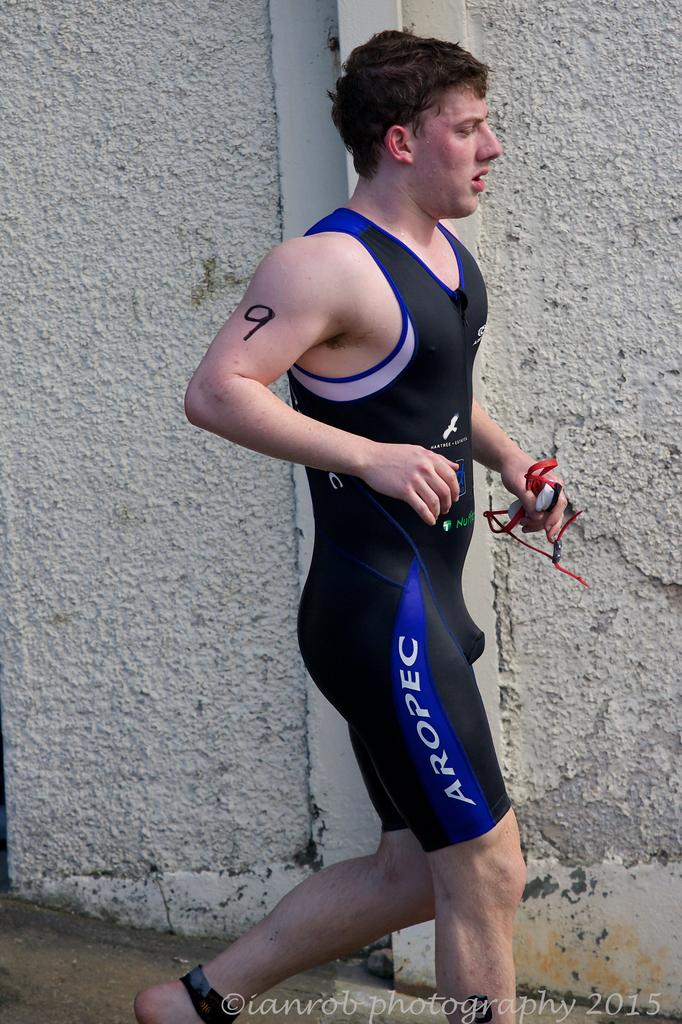<image>
Provide a brief description of the given image. a man wearing AROPEC sportswear and a 9 on his arm.. 